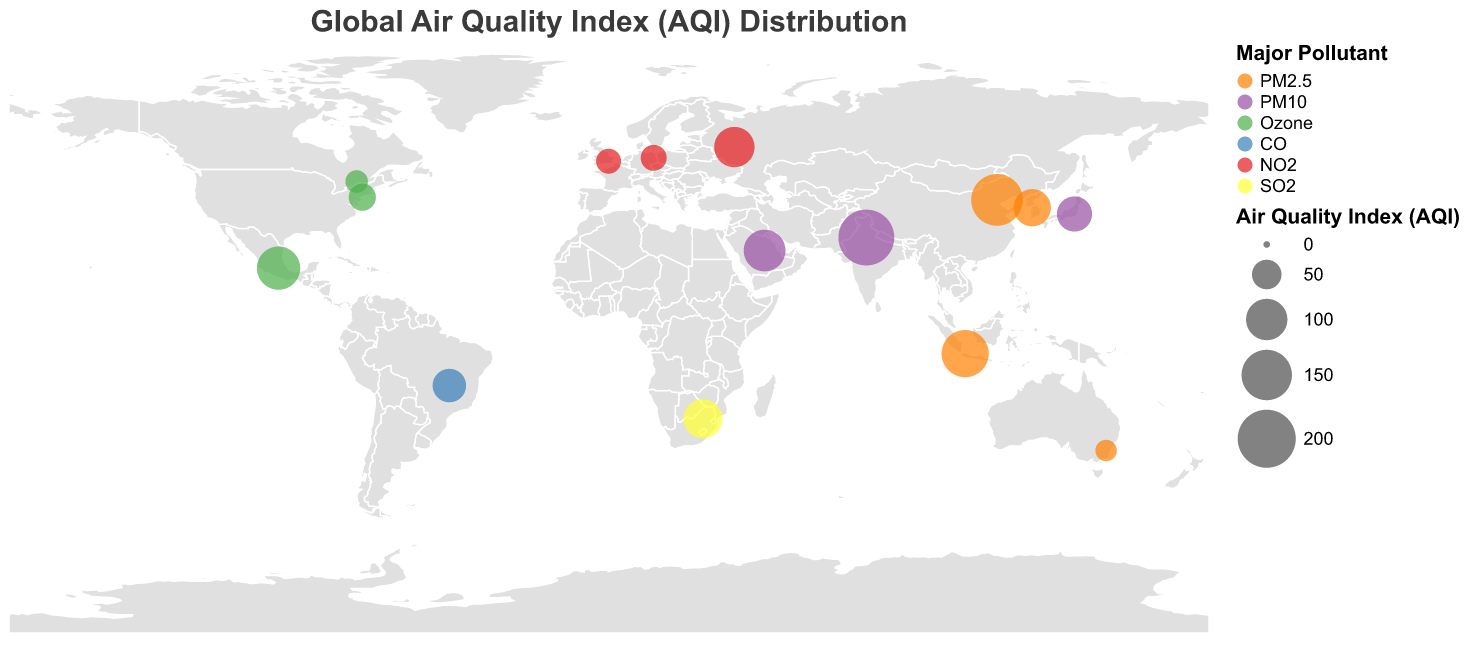What is the title of the geographic plot? The title of the geographic plot is displayed at the top of the map. It is "Global Air Quality Index (AQI) Distribution".
Answer: Global Air Quality Index (AQI) Distribution How many countries are included in the plot? Each circle on the plot represents a country. By counting all the circles, we can determine that there are 15 countries represented in the plot.
Answer: 15 Which country has the highest AQI, and what is its major pollutant? By looking at the size of the circles, we can identify the largest circle corresponds to the highest AQI. This largest circle is located at the coordinates for India, which has an AQI of 185 and the major pollutant is PM10.
Answer: India, PM10 Which pollutant appears most frequently as the major pollutant in the plot? By examining the color representations of each major pollutant and counting how often each appears, PM2.5 is the major pollutant for four countries: China, Australia, Indonesia, and South Korea.
Answer: PM2.5 What is the average AQI of all the countries represented in the plot? Sum the AQI values of all the countries and then divide by the number of countries. The sum is 158 + 185 + 42 + 65 + 38 + 89 + 25 + 72 + 95 + 110 + 131 + 102 + 35 + 28 + 81 = 1256. There are 15 countries, so the average AQI is 1256 / 15 ≈ 83.73.
Answer: 83.73 Which country has the lowest AQI, and what is its major pollutant? The smallest circle on the plot represents the lowest AQI. This smallest circle is located at the coordinates for Australia, which has an AQI of 25 and the major pollutant is PM2.5.
Answer: Australia, PM2.5 Compare the AQI of Brazil and Germany. Which one has a higher AQI and by how much? Brazil and Germany have AQI values of 65 and 38 respectively. By subtracting Germany’s AQI from Brazil’s, we get 65 - 38 = 27. Therefore, Brazil has a higher AQI by 27.
Answer: Brazil, 27 Which country has sulfur dioxide (SO2) as its major pollutant, and what is its AQI level? By referring to the color legend and finding the circle colored for SO2, this country is identified as South Africa with an AQI of 89.
Answer: South Africa, 89 Do any two countries have an equal AQI? By examining the AQI values for each country, we ascertain that no two countries have the same AQI level. Each number is unique.
Answer: No What are the coordinates for the United States, and what is its major pollutant? Locate the circle for the United States on the map plot based on its position and find its major pollutant and coordinates. The coordinates are (40.7128, -74.006) and the major pollutant is Ozone.
Answer: (40.7128, -74.006), Ozone 